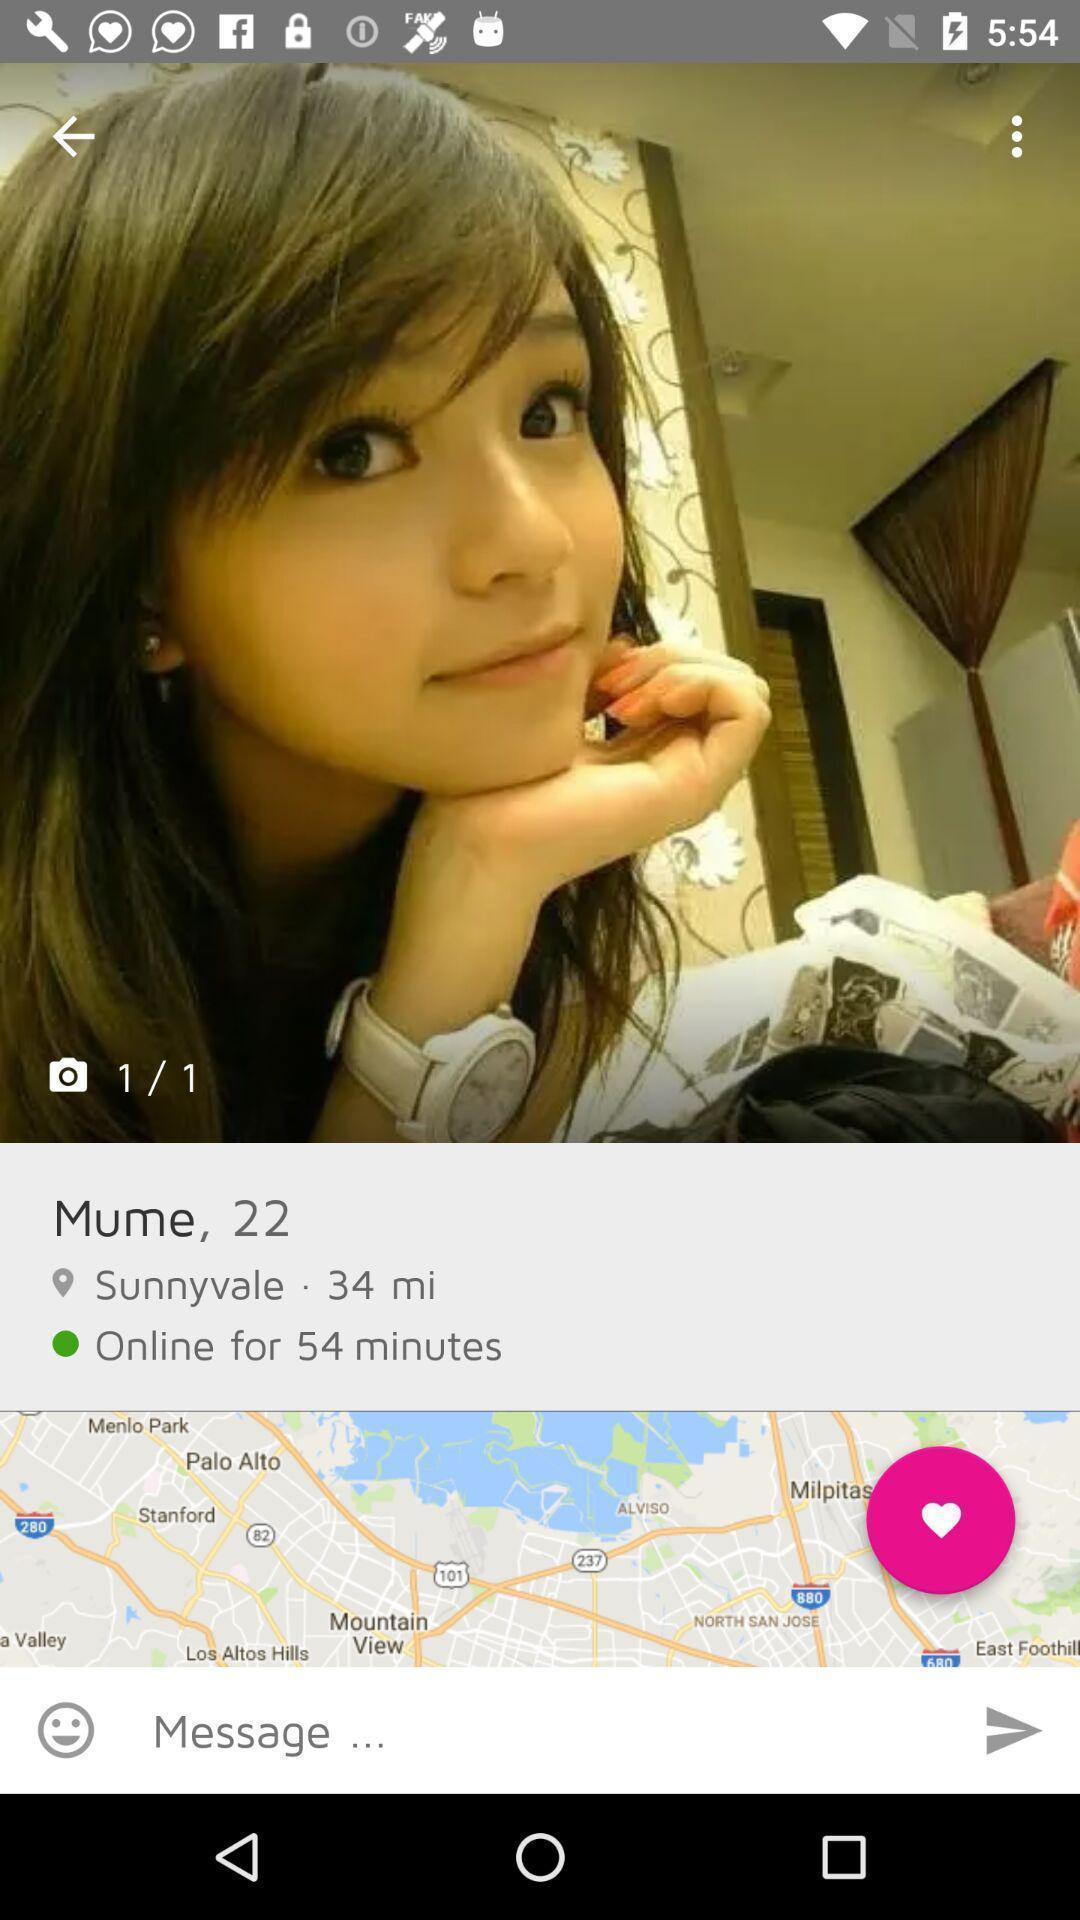Please provide a description for this image. Page showing finding someone like who 's smart. 